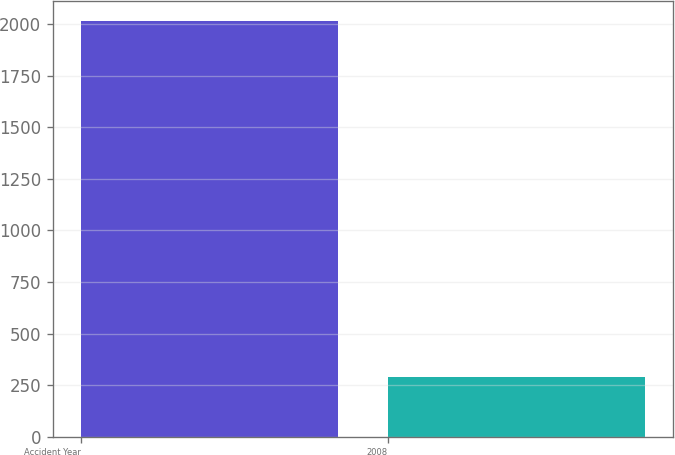Convert chart. <chart><loc_0><loc_0><loc_500><loc_500><bar_chart><fcel>Accident Year<fcel>2008<nl><fcel>2013<fcel>289<nl></chart> 